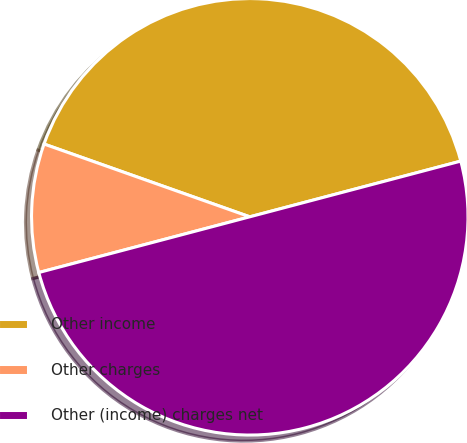Convert chart to OTSL. <chart><loc_0><loc_0><loc_500><loc_500><pie_chart><fcel>Other income<fcel>Other charges<fcel>Other (income) charges net<nl><fcel>40.48%<fcel>9.52%<fcel>50.0%<nl></chart> 